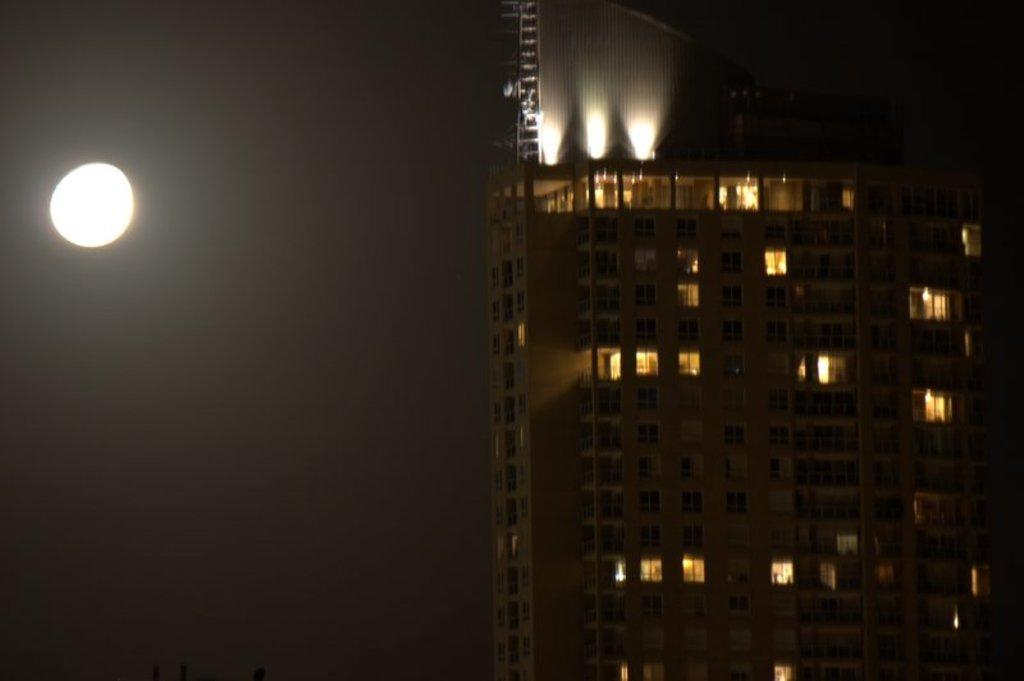What type of structure is located on the right side of the image? There is a very big building on the right side of the image. What can be seen inside the building? There are lights in the building. What is present on the left side of the image? There is a light on the left side of the image. How many horses can be seen grazing in the sand near the building in the image? There are no horses or sand present in the image; it only features a very big building and a light on the left side. 